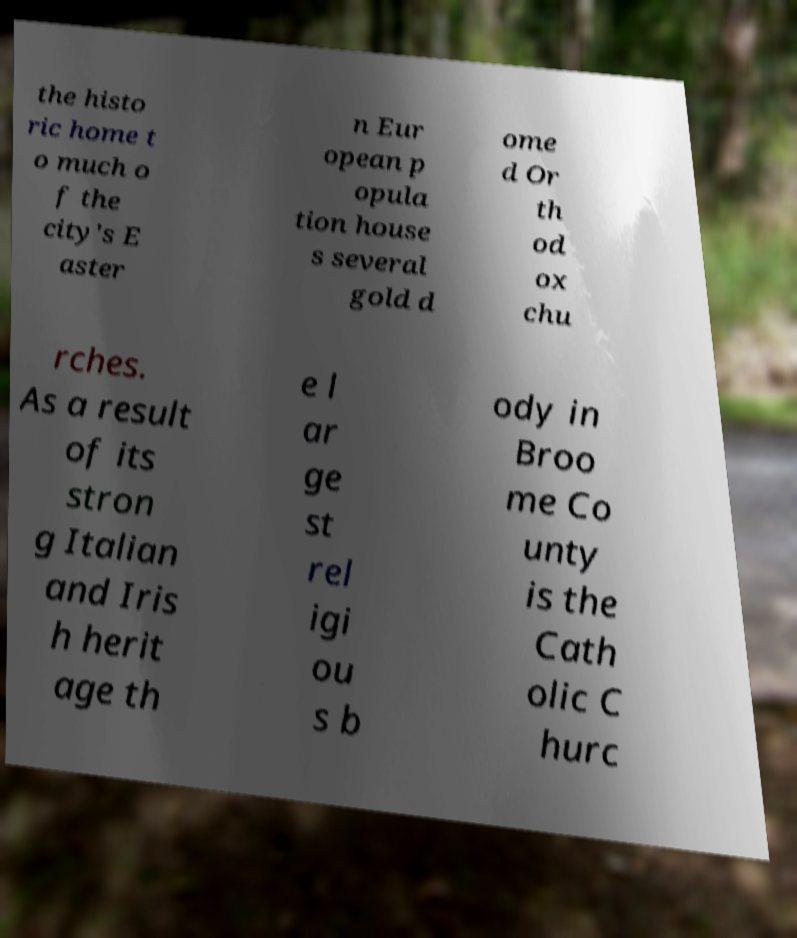Can you accurately transcribe the text from the provided image for me? the histo ric home t o much o f the city's E aster n Eur opean p opula tion house s several gold d ome d Or th od ox chu rches. As a result of its stron g Italian and Iris h herit age th e l ar ge st rel igi ou s b ody in Broo me Co unty is the Cath olic C hurc 